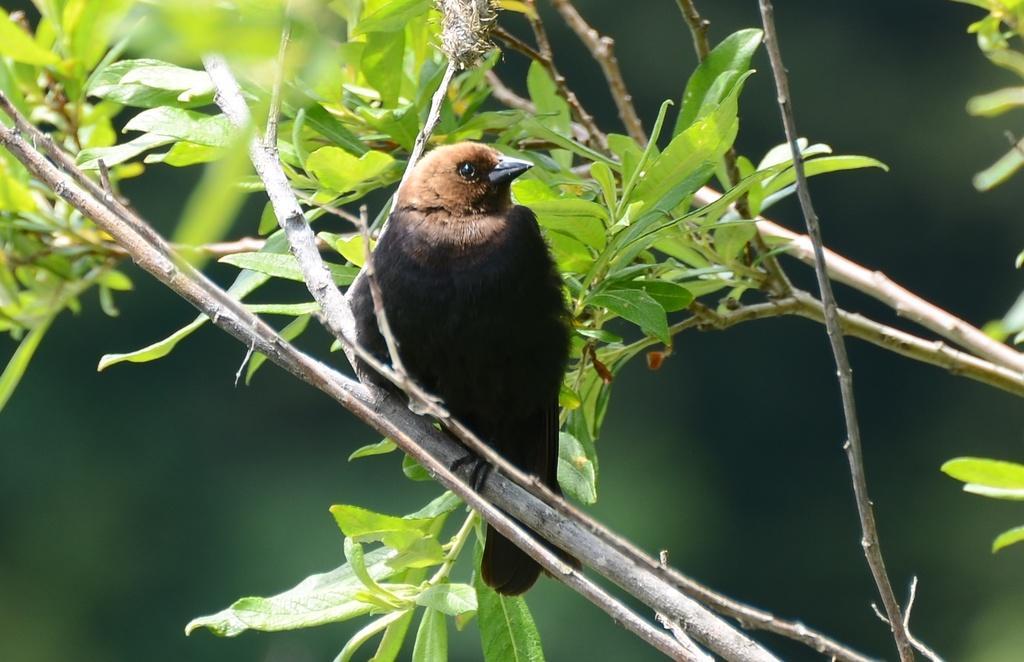Could you give a brief overview of what you see in this image? In this image there is a bird on the tree. The background is blurred. 